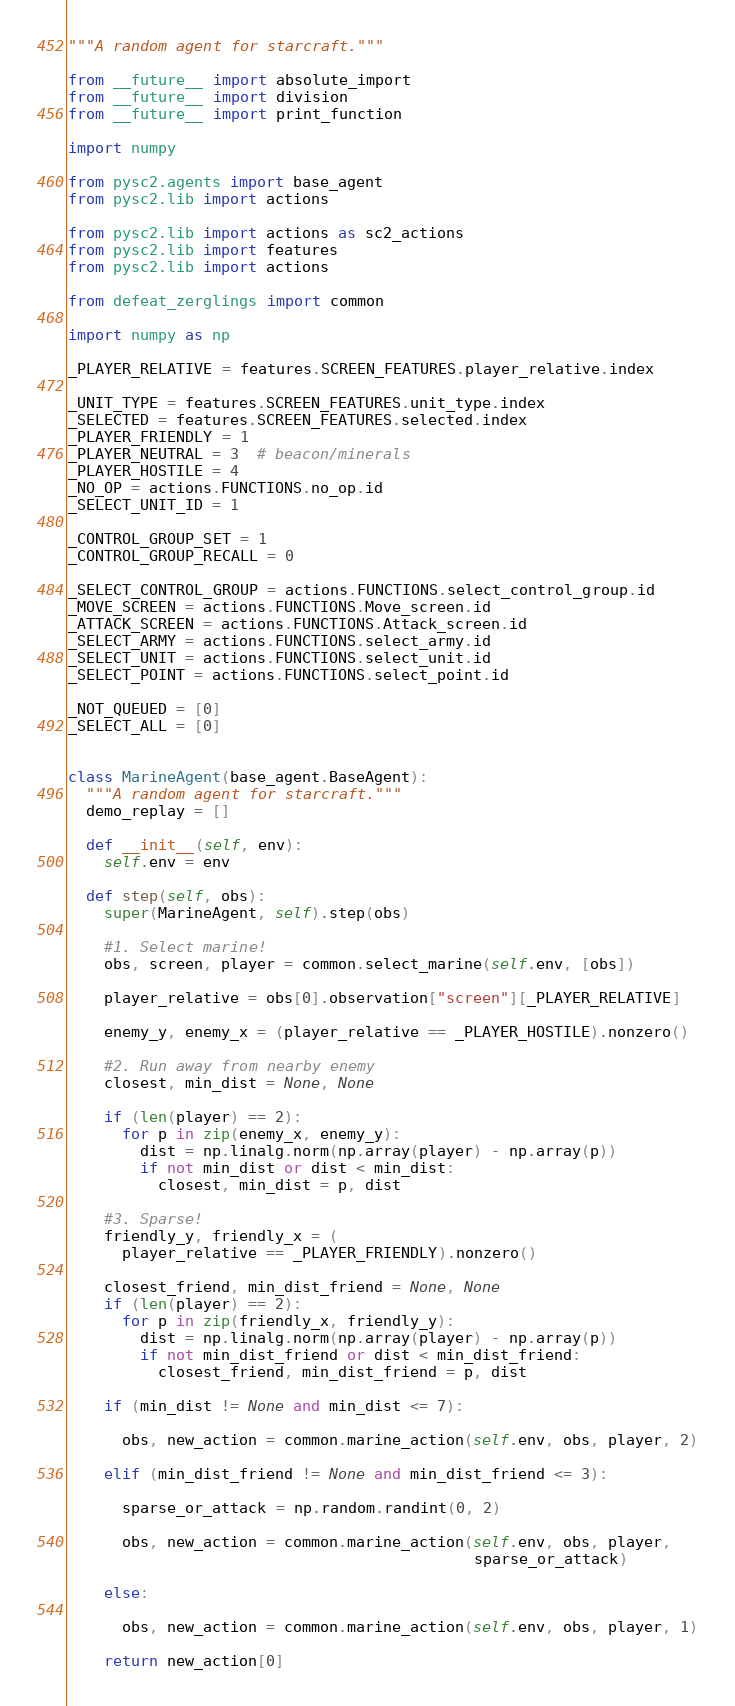Convert code to text. <code><loc_0><loc_0><loc_500><loc_500><_Python_>"""A random agent for starcraft."""

from __future__ import absolute_import
from __future__ import division
from __future__ import print_function

import numpy

from pysc2.agents import base_agent
from pysc2.lib import actions

from pysc2.lib import actions as sc2_actions
from pysc2.lib import features
from pysc2.lib import actions

from defeat_zerglings import common

import numpy as np

_PLAYER_RELATIVE = features.SCREEN_FEATURES.player_relative.index

_UNIT_TYPE = features.SCREEN_FEATURES.unit_type.index
_SELECTED = features.SCREEN_FEATURES.selected.index
_PLAYER_FRIENDLY = 1
_PLAYER_NEUTRAL = 3  # beacon/minerals
_PLAYER_HOSTILE = 4
_NO_OP = actions.FUNCTIONS.no_op.id
_SELECT_UNIT_ID = 1

_CONTROL_GROUP_SET = 1
_CONTROL_GROUP_RECALL = 0

_SELECT_CONTROL_GROUP = actions.FUNCTIONS.select_control_group.id
_MOVE_SCREEN = actions.FUNCTIONS.Move_screen.id
_ATTACK_SCREEN = actions.FUNCTIONS.Attack_screen.id
_SELECT_ARMY = actions.FUNCTIONS.select_army.id
_SELECT_UNIT = actions.FUNCTIONS.select_unit.id
_SELECT_POINT = actions.FUNCTIONS.select_point.id

_NOT_QUEUED = [0]
_SELECT_ALL = [0]


class MarineAgent(base_agent.BaseAgent):
  """A random agent for starcraft."""
  demo_replay = []

  def __init__(self, env):
    self.env = env

  def step(self, obs):
    super(MarineAgent, self).step(obs)

    #1. Select marine!
    obs, screen, player = common.select_marine(self.env, [obs])

    player_relative = obs[0].observation["screen"][_PLAYER_RELATIVE]

    enemy_y, enemy_x = (player_relative == _PLAYER_HOSTILE).nonzero()

    #2. Run away from nearby enemy
    closest, min_dist = None, None

    if (len(player) == 2):
      for p in zip(enemy_x, enemy_y):
        dist = np.linalg.norm(np.array(player) - np.array(p))
        if not min_dist or dist < min_dist:
          closest, min_dist = p, dist

    #3. Sparse!
    friendly_y, friendly_x = (
      player_relative == _PLAYER_FRIENDLY).nonzero()

    closest_friend, min_dist_friend = None, None
    if (len(player) == 2):
      for p in zip(friendly_x, friendly_y):
        dist = np.linalg.norm(np.array(player) - np.array(p))
        if not min_dist_friend or dist < min_dist_friend:
          closest_friend, min_dist_friend = p, dist

    if (min_dist != None and min_dist <= 7):

      obs, new_action = common.marine_action(self.env, obs, player, 2)

    elif (min_dist_friend != None and min_dist_friend <= 3):

      sparse_or_attack = np.random.randint(0, 2)

      obs, new_action = common.marine_action(self.env, obs, player,
                                             sparse_or_attack)

    else:

      obs, new_action = common.marine_action(self.env, obs, player, 1)

    return new_action[0]
</code> 